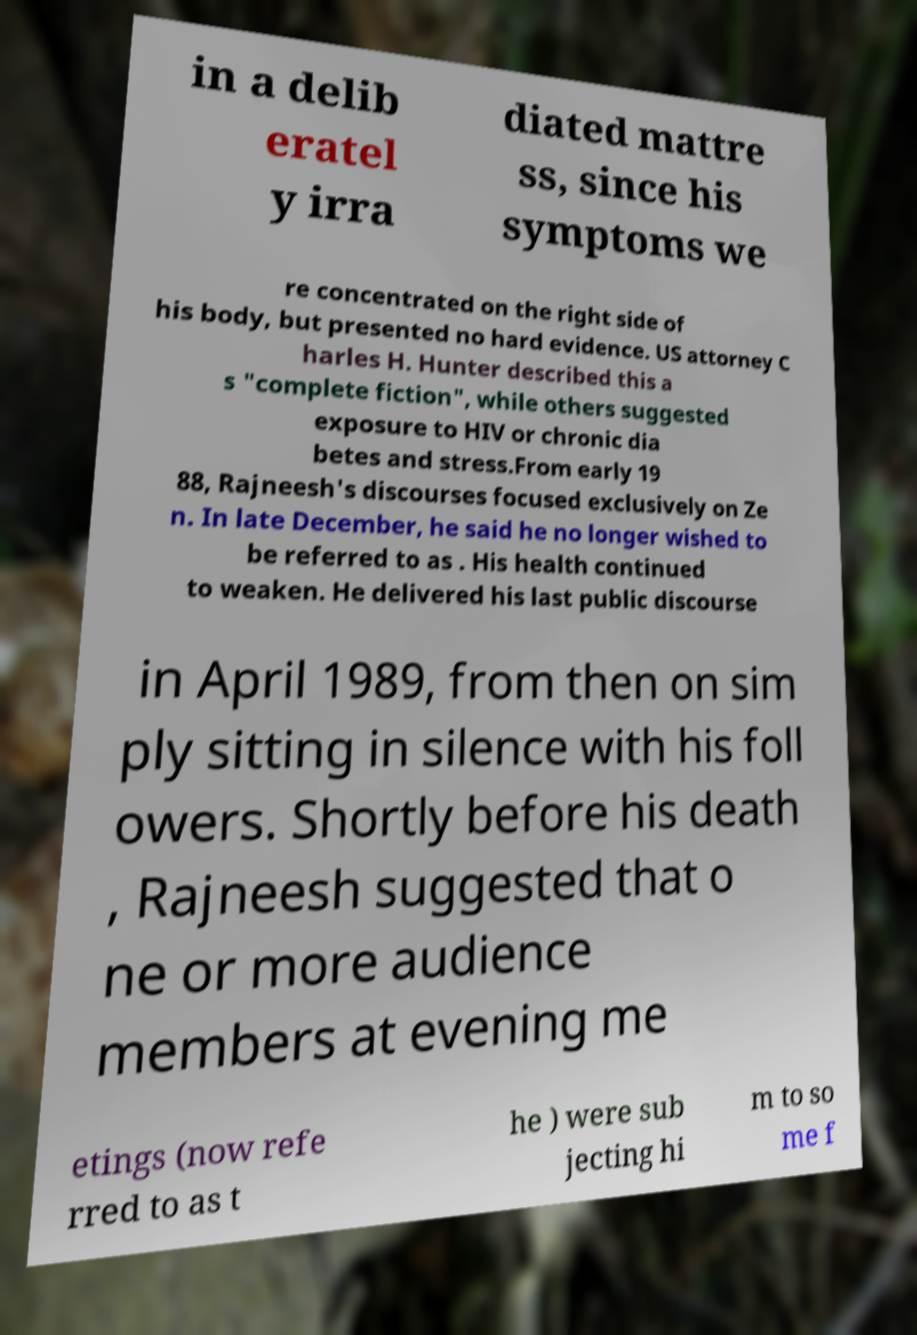Can you accurately transcribe the text from the provided image for me? in a delib eratel y irra diated mattre ss, since his symptoms we re concentrated on the right side of his body, but presented no hard evidence. US attorney C harles H. Hunter described this a s "complete fiction", while others suggested exposure to HIV or chronic dia betes and stress.From early 19 88, Rajneesh's discourses focused exclusively on Ze n. In late December, he said he no longer wished to be referred to as . His health continued to weaken. He delivered his last public discourse in April 1989, from then on sim ply sitting in silence with his foll owers. Shortly before his death , Rajneesh suggested that o ne or more audience members at evening me etings (now refe rred to as t he ) were sub jecting hi m to so me f 